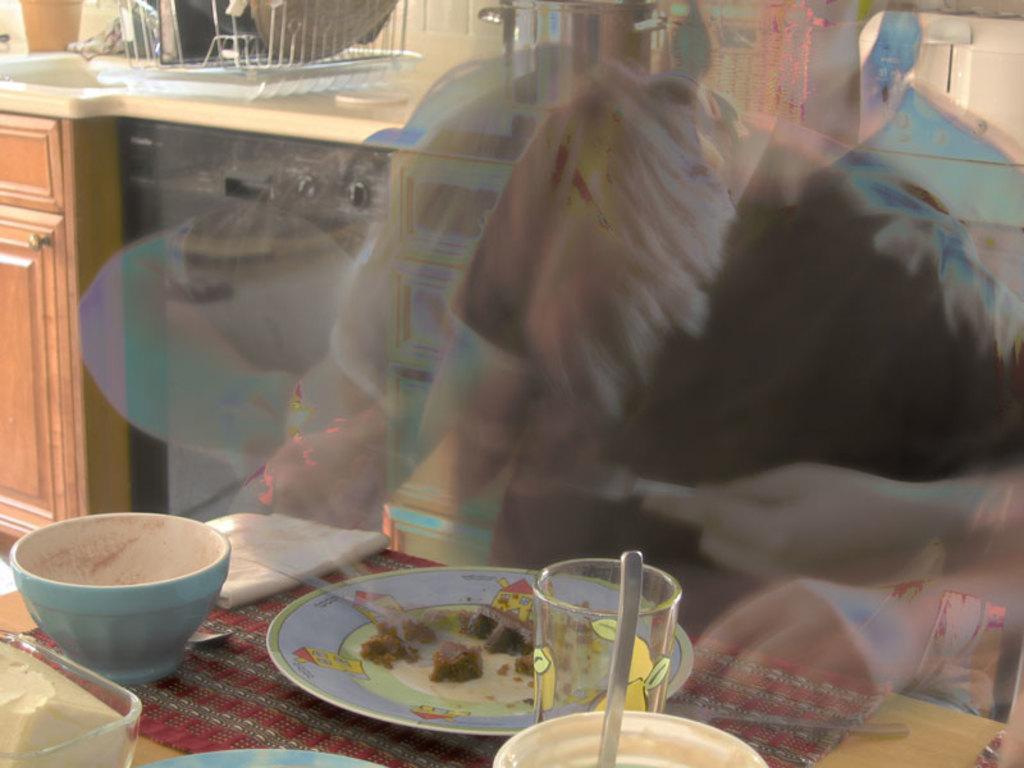In one or two sentences, can you explain what this image depicts? This looks like an edited image. Here is a person. This is the table with a dining mat. I can see a bowl, plate, glass, tissue paper, spoon and few other objects on it. This looks like a cupboard with door. I think this is the kitchen cabinet. I can see an object, which is white in color. 